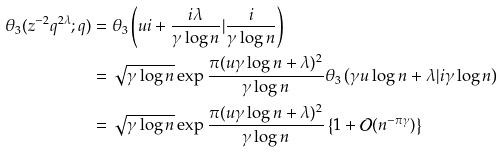Convert formula to latex. <formula><loc_0><loc_0><loc_500><loc_500>\theta _ { 3 } ( z ^ { - 2 } q ^ { 2 \lambda } ; q ) & = \theta _ { 3 } \left ( u i + \frac { i \lambda } { \gamma \log n } | \frac { i } { \gamma \log n } \right ) \\ & = \sqrt { \gamma \log n } \exp \frac { \pi ( u \gamma \log n + \lambda ) ^ { 2 } } { \gamma \log n } \theta _ { 3 } \left ( \gamma u \log n + \lambda | i \gamma \log n \right ) \\ & = \sqrt { \gamma \log n } \exp \frac { \pi ( u \gamma \log n + \lambda ) ^ { 2 } } { \gamma \log n } \left \{ 1 + \mathcal { O } ( n ^ { - \pi \gamma } ) \right \}</formula> 